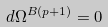Convert formula to latex. <formula><loc_0><loc_0><loc_500><loc_500>d \Omega ^ { B ( p + 1 ) } = 0</formula> 